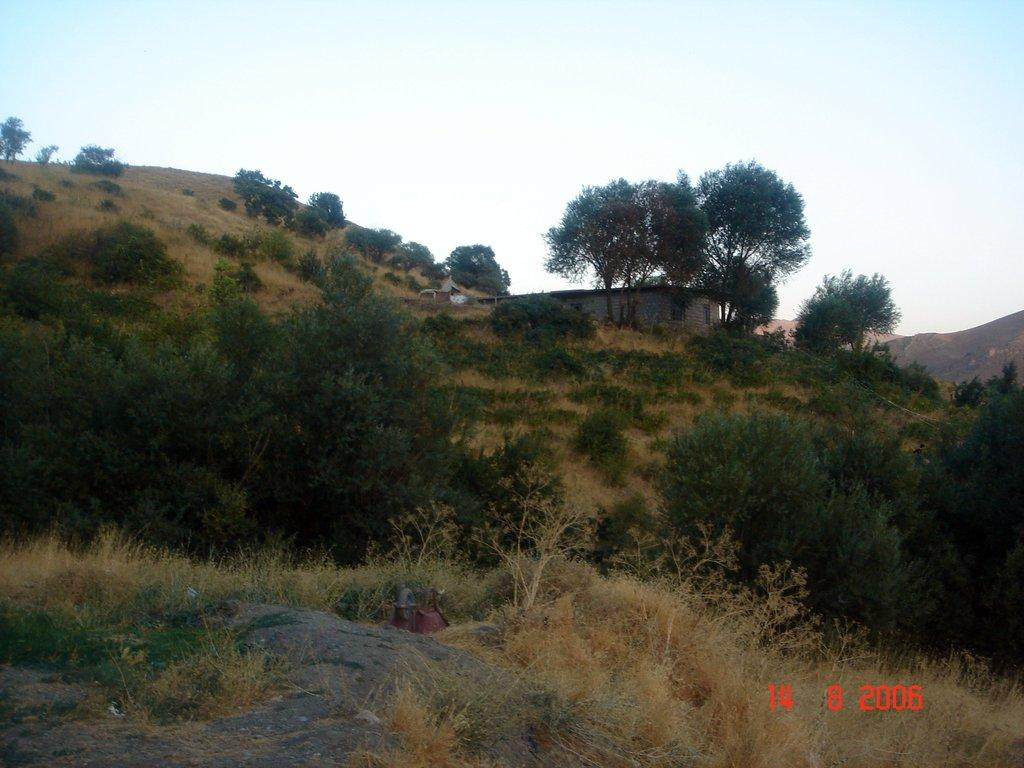What is located in the front of the image? There is a rock in the front of the image. What type of vegetation can be seen in the image? There are plants in the image. Where is the house located in the image? The house is on the right side of the image. What natural features are visible in the background of the image? There are mountains visible in the image. What is visible at the top of the image? The sky is visible at the top of the image. Can you tell me how many pockets are on the grandmother's dress in the image? There is no grandmother or dress present in the image; it features a rock, plants, a house, mountains, and the sky. What type of sun is visible in the image? There is no sun present in the image; only the sky is visible at the top of the image. 